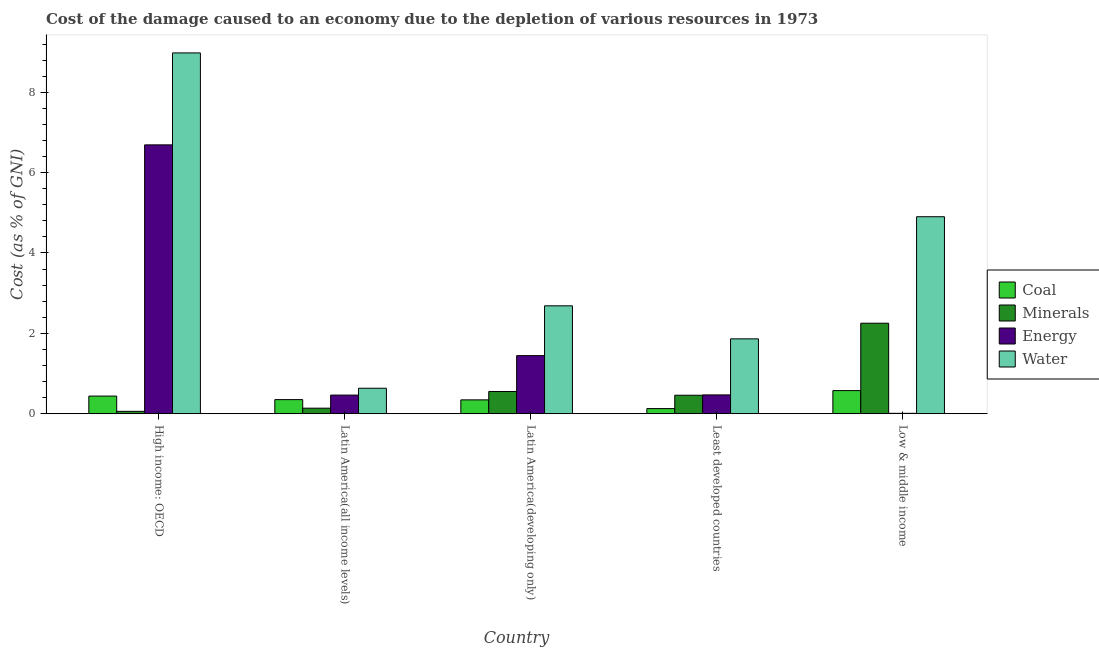How many groups of bars are there?
Offer a terse response. 5. Are the number of bars per tick equal to the number of legend labels?
Your answer should be very brief. Yes. How many bars are there on the 5th tick from the left?
Provide a short and direct response. 4. How many bars are there on the 1st tick from the right?
Give a very brief answer. 4. What is the label of the 2nd group of bars from the left?
Your answer should be compact. Latin America(all income levels). In how many cases, is the number of bars for a given country not equal to the number of legend labels?
Give a very brief answer. 0. What is the cost of damage due to depletion of energy in Least developed countries?
Make the answer very short. 0.47. Across all countries, what is the maximum cost of damage due to depletion of coal?
Your answer should be very brief. 0.58. Across all countries, what is the minimum cost of damage due to depletion of energy?
Your response must be concise. 0.01. In which country was the cost of damage due to depletion of energy maximum?
Keep it short and to the point. High income: OECD. What is the total cost of damage due to depletion of minerals in the graph?
Your response must be concise. 3.46. What is the difference between the cost of damage due to depletion of water in Latin America(developing only) and that in Low & middle income?
Offer a terse response. -2.22. What is the difference between the cost of damage due to depletion of water in Latin America(developing only) and the cost of damage due to depletion of energy in Least developed countries?
Give a very brief answer. 2.22. What is the average cost of damage due to depletion of energy per country?
Keep it short and to the point. 1.82. What is the difference between the cost of damage due to depletion of minerals and cost of damage due to depletion of energy in Least developed countries?
Ensure brevity in your answer.  -0.01. In how many countries, is the cost of damage due to depletion of energy greater than 1.6 %?
Make the answer very short. 1. What is the ratio of the cost of damage due to depletion of water in High income: OECD to that in Latin America(developing only)?
Provide a short and direct response. 3.34. What is the difference between the highest and the second highest cost of damage due to depletion of water?
Make the answer very short. 4.08. What is the difference between the highest and the lowest cost of damage due to depletion of coal?
Your response must be concise. 0.45. In how many countries, is the cost of damage due to depletion of water greater than the average cost of damage due to depletion of water taken over all countries?
Ensure brevity in your answer.  2. Is the sum of the cost of damage due to depletion of water in High income: OECD and Latin America(all income levels) greater than the maximum cost of damage due to depletion of energy across all countries?
Keep it short and to the point. Yes. What does the 2nd bar from the left in High income: OECD represents?
Your answer should be compact. Minerals. What does the 4th bar from the right in Latin America(developing only) represents?
Your answer should be compact. Coal. Is it the case that in every country, the sum of the cost of damage due to depletion of coal and cost of damage due to depletion of minerals is greater than the cost of damage due to depletion of energy?
Offer a terse response. No. What is the difference between two consecutive major ticks on the Y-axis?
Ensure brevity in your answer.  2. Does the graph contain any zero values?
Your response must be concise. No. Where does the legend appear in the graph?
Your response must be concise. Center right. How are the legend labels stacked?
Provide a short and direct response. Vertical. What is the title of the graph?
Your answer should be very brief. Cost of the damage caused to an economy due to the depletion of various resources in 1973 . What is the label or title of the X-axis?
Give a very brief answer. Country. What is the label or title of the Y-axis?
Ensure brevity in your answer.  Cost (as % of GNI). What is the Cost (as % of GNI) of Coal in High income: OECD?
Your answer should be compact. 0.44. What is the Cost (as % of GNI) in Minerals in High income: OECD?
Your answer should be very brief. 0.06. What is the Cost (as % of GNI) of Energy in High income: OECD?
Give a very brief answer. 6.69. What is the Cost (as % of GNI) in Water in High income: OECD?
Make the answer very short. 8.98. What is the Cost (as % of GNI) in Coal in Latin America(all income levels)?
Your answer should be compact. 0.35. What is the Cost (as % of GNI) of Minerals in Latin America(all income levels)?
Give a very brief answer. 0.14. What is the Cost (as % of GNI) in Energy in Latin America(all income levels)?
Keep it short and to the point. 0.46. What is the Cost (as % of GNI) in Water in Latin America(all income levels)?
Your answer should be compact. 0.63. What is the Cost (as % of GNI) in Coal in Latin America(developing only)?
Ensure brevity in your answer.  0.35. What is the Cost (as % of GNI) in Minerals in Latin America(developing only)?
Provide a short and direct response. 0.55. What is the Cost (as % of GNI) of Energy in Latin America(developing only)?
Your response must be concise. 1.45. What is the Cost (as % of GNI) of Water in Latin America(developing only)?
Your answer should be very brief. 2.69. What is the Cost (as % of GNI) in Coal in Least developed countries?
Provide a short and direct response. 0.13. What is the Cost (as % of GNI) in Minerals in Least developed countries?
Provide a succinct answer. 0.46. What is the Cost (as % of GNI) in Energy in Least developed countries?
Your answer should be compact. 0.47. What is the Cost (as % of GNI) of Water in Least developed countries?
Offer a very short reply. 1.86. What is the Cost (as % of GNI) of Coal in Low & middle income?
Offer a very short reply. 0.58. What is the Cost (as % of GNI) in Minerals in Low & middle income?
Make the answer very short. 2.25. What is the Cost (as % of GNI) of Energy in Low & middle income?
Offer a very short reply. 0.01. What is the Cost (as % of GNI) in Water in Low & middle income?
Provide a short and direct response. 4.9. Across all countries, what is the maximum Cost (as % of GNI) of Coal?
Give a very brief answer. 0.58. Across all countries, what is the maximum Cost (as % of GNI) in Minerals?
Your answer should be compact. 2.25. Across all countries, what is the maximum Cost (as % of GNI) of Energy?
Your answer should be compact. 6.69. Across all countries, what is the maximum Cost (as % of GNI) of Water?
Offer a terse response. 8.98. Across all countries, what is the minimum Cost (as % of GNI) in Coal?
Give a very brief answer. 0.13. Across all countries, what is the minimum Cost (as % of GNI) in Minerals?
Your response must be concise. 0.06. Across all countries, what is the minimum Cost (as % of GNI) of Energy?
Offer a very short reply. 0.01. Across all countries, what is the minimum Cost (as % of GNI) in Water?
Make the answer very short. 0.63. What is the total Cost (as % of GNI) in Coal in the graph?
Your response must be concise. 1.84. What is the total Cost (as % of GNI) of Minerals in the graph?
Make the answer very short. 3.46. What is the total Cost (as % of GNI) in Energy in the graph?
Make the answer very short. 9.08. What is the total Cost (as % of GNI) of Water in the graph?
Provide a succinct answer. 19.06. What is the difference between the Cost (as % of GNI) of Coal in High income: OECD and that in Latin America(all income levels)?
Your response must be concise. 0.09. What is the difference between the Cost (as % of GNI) of Minerals in High income: OECD and that in Latin America(all income levels)?
Ensure brevity in your answer.  -0.08. What is the difference between the Cost (as % of GNI) in Energy in High income: OECD and that in Latin America(all income levels)?
Ensure brevity in your answer.  6.23. What is the difference between the Cost (as % of GNI) in Water in High income: OECD and that in Latin America(all income levels)?
Your answer should be compact. 8.34. What is the difference between the Cost (as % of GNI) of Coal in High income: OECD and that in Latin America(developing only)?
Make the answer very short. 0.09. What is the difference between the Cost (as % of GNI) in Minerals in High income: OECD and that in Latin America(developing only)?
Provide a succinct answer. -0.49. What is the difference between the Cost (as % of GNI) of Energy in High income: OECD and that in Latin America(developing only)?
Your answer should be very brief. 5.24. What is the difference between the Cost (as % of GNI) of Water in High income: OECD and that in Latin America(developing only)?
Keep it short and to the point. 6.29. What is the difference between the Cost (as % of GNI) in Coal in High income: OECD and that in Least developed countries?
Provide a succinct answer. 0.31. What is the difference between the Cost (as % of GNI) in Minerals in High income: OECD and that in Least developed countries?
Offer a terse response. -0.4. What is the difference between the Cost (as % of GNI) in Energy in High income: OECD and that in Least developed countries?
Offer a very short reply. 6.22. What is the difference between the Cost (as % of GNI) in Water in High income: OECD and that in Least developed countries?
Provide a short and direct response. 7.12. What is the difference between the Cost (as % of GNI) in Coal in High income: OECD and that in Low & middle income?
Offer a terse response. -0.14. What is the difference between the Cost (as % of GNI) of Minerals in High income: OECD and that in Low & middle income?
Your response must be concise. -2.19. What is the difference between the Cost (as % of GNI) in Energy in High income: OECD and that in Low & middle income?
Offer a terse response. 6.68. What is the difference between the Cost (as % of GNI) in Water in High income: OECD and that in Low & middle income?
Ensure brevity in your answer.  4.08. What is the difference between the Cost (as % of GNI) of Coal in Latin America(all income levels) and that in Latin America(developing only)?
Provide a succinct answer. 0.01. What is the difference between the Cost (as % of GNI) in Minerals in Latin America(all income levels) and that in Latin America(developing only)?
Make the answer very short. -0.42. What is the difference between the Cost (as % of GNI) in Energy in Latin America(all income levels) and that in Latin America(developing only)?
Provide a short and direct response. -0.98. What is the difference between the Cost (as % of GNI) of Water in Latin America(all income levels) and that in Latin America(developing only)?
Ensure brevity in your answer.  -2.05. What is the difference between the Cost (as % of GNI) in Coal in Latin America(all income levels) and that in Least developed countries?
Your response must be concise. 0.22. What is the difference between the Cost (as % of GNI) of Minerals in Latin America(all income levels) and that in Least developed countries?
Offer a terse response. -0.32. What is the difference between the Cost (as % of GNI) of Energy in Latin America(all income levels) and that in Least developed countries?
Make the answer very short. -0. What is the difference between the Cost (as % of GNI) in Water in Latin America(all income levels) and that in Least developed countries?
Give a very brief answer. -1.23. What is the difference between the Cost (as % of GNI) of Coal in Latin America(all income levels) and that in Low & middle income?
Provide a succinct answer. -0.22. What is the difference between the Cost (as % of GNI) in Minerals in Latin America(all income levels) and that in Low & middle income?
Offer a very short reply. -2.11. What is the difference between the Cost (as % of GNI) in Energy in Latin America(all income levels) and that in Low & middle income?
Make the answer very short. 0.45. What is the difference between the Cost (as % of GNI) of Water in Latin America(all income levels) and that in Low & middle income?
Provide a short and direct response. -4.27. What is the difference between the Cost (as % of GNI) of Coal in Latin America(developing only) and that in Least developed countries?
Offer a terse response. 0.22. What is the difference between the Cost (as % of GNI) of Minerals in Latin America(developing only) and that in Least developed countries?
Provide a short and direct response. 0.09. What is the difference between the Cost (as % of GNI) in Energy in Latin America(developing only) and that in Least developed countries?
Ensure brevity in your answer.  0.98. What is the difference between the Cost (as % of GNI) of Water in Latin America(developing only) and that in Least developed countries?
Your answer should be very brief. 0.82. What is the difference between the Cost (as % of GNI) of Coal in Latin America(developing only) and that in Low & middle income?
Provide a short and direct response. -0.23. What is the difference between the Cost (as % of GNI) of Minerals in Latin America(developing only) and that in Low & middle income?
Your answer should be compact. -1.7. What is the difference between the Cost (as % of GNI) in Energy in Latin America(developing only) and that in Low & middle income?
Ensure brevity in your answer.  1.44. What is the difference between the Cost (as % of GNI) of Water in Latin America(developing only) and that in Low & middle income?
Your answer should be very brief. -2.22. What is the difference between the Cost (as % of GNI) in Coal in Least developed countries and that in Low & middle income?
Provide a short and direct response. -0.45. What is the difference between the Cost (as % of GNI) in Minerals in Least developed countries and that in Low & middle income?
Provide a short and direct response. -1.79. What is the difference between the Cost (as % of GNI) in Energy in Least developed countries and that in Low & middle income?
Your answer should be compact. 0.46. What is the difference between the Cost (as % of GNI) in Water in Least developed countries and that in Low & middle income?
Ensure brevity in your answer.  -3.04. What is the difference between the Cost (as % of GNI) in Coal in High income: OECD and the Cost (as % of GNI) in Minerals in Latin America(all income levels)?
Your answer should be very brief. 0.3. What is the difference between the Cost (as % of GNI) of Coal in High income: OECD and the Cost (as % of GNI) of Energy in Latin America(all income levels)?
Provide a short and direct response. -0.02. What is the difference between the Cost (as % of GNI) of Coal in High income: OECD and the Cost (as % of GNI) of Water in Latin America(all income levels)?
Your response must be concise. -0.2. What is the difference between the Cost (as % of GNI) of Minerals in High income: OECD and the Cost (as % of GNI) of Energy in Latin America(all income levels)?
Offer a very short reply. -0.4. What is the difference between the Cost (as % of GNI) in Minerals in High income: OECD and the Cost (as % of GNI) in Water in Latin America(all income levels)?
Provide a short and direct response. -0.57. What is the difference between the Cost (as % of GNI) in Energy in High income: OECD and the Cost (as % of GNI) in Water in Latin America(all income levels)?
Make the answer very short. 6.06. What is the difference between the Cost (as % of GNI) of Coal in High income: OECD and the Cost (as % of GNI) of Minerals in Latin America(developing only)?
Offer a terse response. -0.11. What is the difference between the Cost (as % of GNI) in Coal in High income: OECD and the Cost (as % of GNI) in Energy in Latin America(developing only)?
Provide a short and direct response. -1.01. What is the difference between the Cost (as % of GNI) of Coal in High income: OECD and the Cost (as % of GNI) of Water in Latin America(developing only)?
Offer a very short reply. -2.25. What is the difference between the Cost (as % of GNI) of Minerals in High income: OECD and the Cost (as % of GNI) of Energy in Latin America(developing only)?
Offer a terse response. -1.39. What is the difference between the Cost (as % of GNI) of Minerals in High income: OECD and the Cost (as % of GNI) of Water in Latin America(developing only)?
Provide a succinct answer. -2.63. What is the difference between the Cost (as % of GNI) of Energy in High income: OECD and the Cost (as % of GNI) of Water in Latin America(developing only)?
Your answer should be very brief. 4.01. What is the difference between the Cost (as % of GNI) in Coal in High income: OECD and the Cost (as % of GNI) in Minerals in Least developed countries?
Provide a succinct answer. -0.02. What is the difference between the Cost (as % of GNI) of Coal in High income: OECD and the Cost (as % of GNI) of Energy in Least developed countries?
Provide a short and direct response. -0.03. What is the difference between the Cost (as % of GNI) in Coal in High income: OECD and the Cost (as % of GNI) in Water in Least developed countries?
Offer a terse response. -1.42. What is the difference between the Cost (as % of GNI) of Minerals in High income: OECD and the Cost (as % of GNI) of Energy in Least developed countries?
Provide a short and direct response. -0.41. What is the difference between the Cost (as % of GNI) of Minerals in High income: OECD and the Cost (as % of GNI) of Water in Least developed countries?
Give a very brief answer. -1.8. What is the difference between the Cost (as % of GNI) in Energy in High income: OECD and the Cost (as % of GNI) in Water in Least developed countries?
Provide a short and direct response. 4.83. What is the difference between the Cost (as % of GNI) in Coal in High income: OECD and the Cost (as % of GNI) in Minerals in Low & middle income?
Offer a very short reply. -1.81. What is the difference between the Cost (as % of GNI) of Coal in High income: OECD and the Cost (as % of GNI) of Energy in Low & middle income?
Offer a terse response. 0.43. What is the difference between the Cost (as % of GNI) of Coal in High income: OECD and the Cost (as % of GNI) of Water in Low & middle income?
Your response must be concise. -4.46. What is the difference between the Cost (as % of GNI) of Minerals in High income: OECD and the Cost (as % of GNI) of Energy in Low & middle income?
Ensure brevity in your answer.  0.05. What is the difference between the Cost (as % of GNI) of Minerals in High income: OECD and the Cost (as % of GNI) of Water in Low & middle income?
Offer a very short reply. -4.84. What is the difference between the Cost (as % of GNI) in Energy in High income: OECD and the Cost (as % of GNI) in Water in Low & middle income?
Provide a succinct answer. 1.79. What is the difference between the Cost (as % of GNI) of Coal in Latin America(all income levels) and the Cost (as % of GNI) of Minerals in Latin America(developing only)?
Give a very brief answer. -0.2. What is the difference between the Cost (as % of GNI) of Coal in Latin America(all income levels) and the Cost (as % of GNI) of Energy in Latin America(developing only)?
Offer a terse response. -1.09. What is the difference between the Cost (as % of GNI) of Coal in Latin America(all income levels) and the Cost (as % of GNI) of Water in Latin America(developing only)?
Your answer should be very brief. -2.33. What is the difference between the Cost (as % of GNI) of Minerals in Latin America(all income levels) and the Cost (as % of GNI) of Energy in Latin America(developing only)?
Provide a short and direct response. -1.31. What is the difference between the Cost (as % of GNI) of Minerals in Latin America(all income levels) and the Cost (as % of GNI) of Water in Latin America(developing only)?
Provide a succinct answer. -2.55. What is the difference between the Cost (as % of GNI) in Energy in Latin America(all income levels) and the Cost (as % of GNI) in Water in Latin America(developing only)?
Give a very brief answer. -2.22. What is the difference between the Cost (as % of GNI) of Coal in Latin America(all income levels) and the Cost (as % of GNI) of Minerals in Least developed countries?
Ensure brevity in your answer.  -0.11. What is the difference between the Cost (as % of GNI) of Coal in Latin America(all income levels) and the Cost (as % of GNI) of Energy in Least developed countries?
Your answer should be compact. -0.12. What is the difference between the Cost (as % of GNI) in Coal in Latin America(all income levels) and the Cost (as % of GNI) in Water in Least developed countries?
Your response must be concise. -1.51. What is the difference between the Cost (as % of GNI) in Minerals in Latin America(all income levels) and the Cost (as % of GNI) in Energy in Least developed countries?
Provide a succinct answer. -0.33. What is the difference between the Cost (as % of GNI) in Minerals in Latin America(all income levels) and the Cost (as % of GNI) in Water in Least developed countries?
Offer a terse response. -1.73. What is the difference between the Cost (as % of GNI) in Energy in Latin America(all income levels) and the Cost (as % of GNI) in Water in Least developed countries?
Keep it short and to the point. -1.4. What is the difference between the Cost (as % of GNI) of Coal in Latin America(all income levels) and the Cost (as % of GNI) of Minerals in Low & middle income?
Make the answer very short. -1.9. What is the difference between the Cost (as % of GNI) of Coal in Latin America(all income levels) and the Cost (as % of GNI) of Energy in Low & middle income?
Keep it short and to the point. 0.34. What is the difference between the Cost (as % of GNI) of Coal in Latin America(all income levels) and the Cost (as % of GNI) of Water in Low & middle income?
Provide a succinct answer. -4.55. What is the difference between the Cost (as % of GNI) of Minerals in Latin America(all income levels) and the Cost (as % of GNI) of Energy in Low & middle income?
Give a very brief answer. 0.13. What is the difference between the Cost (as % of GNI) in Minerals in Latin America(all income levels) and the Cost (as % of GNI) in Water in Low & middle income?
Your answer should be compact. -4.76. What is the difference between the Cost (as % of GNI) in Energy in Latin America(all income levels) and the Cost (as % of GNI) in Water in Low & middle income?
Your answer should be very brief. -4.44. What is the difference between the Cost (as % of GNI) of Coal in Latin America(developing only) and the Cost (as % of GNI) of Minerals in Least developed countries?
Ensure brevity in your answer.  -0.12. What is the difference between the Cost (as % of GNI) of Coal in Latin America(developing only) and the Cost (as % of GNI) of Energy in Least developed countries?
Your response must be concise. -0.12. What is the difference between the Cost (as % of GNI) in Coal in Latin America(developing only) and the Cost (as % of GNI) in Water in Least developed countries?
Make the answer very short. -1.52. What is the difference between the Cost (as % of GNI) in Minerals in Latin America(developing only) and the Cost (as % of GNI) in Energy in Least developed countries?
Keep it short and to the point. 0.09. What is the difference between the Cost (as % of GNI) in Minerals in Latin America(developing only) and the Cost (as % of GNI) in Water in Least developed countries?
Keep it short and to the point. -1.31. What is the difference between the Cost (as % of GNI) of Energy in Latin America(developing only) and the Cost (as % of GNI) of Water in Least developed countries?
Your answer should be very brief. -0.42. What is the difference between the Cost (as % of GNI) of Coal in Latin America(developing only) and the Cost (as % of GNI) of Minerals in Low & middle income?
Provide a succinct answer. -1.91. What is the difference between the Cost (as % of GNI) in Coal in Latin America(developing only) and the Cost (as % of GNI) in Energy in Low & middle income?
Offer a very short reply. 0.33. What is the difference between the Cost (as % of GNI) in Coal in Latin America(developing only) and the Cost (as % of GNI) in Water in Low & middle income?
Your answer should be compact. -4.56. What is the difference between the Cost (as % of GNI) in Minerals in Latin America(developing only) and the Cost (as % of GNI) in Energy in Low & middle income?
Keep it short and to the point. 0.54. What is the difference between the Cost (as % of GNI) of Minerals in Latin America(developing only) and the Cost (as % of GNI) of Water in Low & middle income?
Offer a very short reply. -4.35. What is the difference between the Cost (as % of GNI) of Energy in Latin America(developing only) and the Cost (as % of GNI) of Water in Low & middle income?
Your response must be concise. -3.46. What is the difference between the Cost (as % of GNI) in Coal in Least developed countries and the Cost (as % of GNI) in Minerals in Low & middle income?
Keep it short and to the point. -2.12. What is the difference between the Cost (as % of GNI) of Coal in Least developed countries and the Cost (as % of GNI) of Energy in Low & middle income?
Provide a short and direct response. 0.12. What is the difference between the Cost (as % of GNI) in Coal in Least developed countries and the Cost (as % of GNI) in Water in Low & middle income?
Provide a succinct answer. -4.77. What is the difference between the Cost (as % of GNI) of Minerals in Least developed countries and the Cost (as % of GNI) of Energy in Low & middle income?
Your answer should be very brief. 0.45. What is the difference between the Cost (as % of GNI) in Minerals in Least developed countries and the Cost (as % of GNI) in Water in Low & middle income?
Provide a short and direct response. -4.44. What is the difference between the Cost (as % of GNI) in Energy in Least developed countries and the Cost (as % of GNI) in Water in Low & middle income?
Provide a short and direct response. -4.43. What is the average Cost (as % of GNI) of Coal per country?
Offer a very short reply. 0.37. What is the average Cost (as % of GNI) in Minerals per country?
Your answer should be very brief. 0.69. What is the average Cost (as % of GNI) of Energy per country?
Provide a short and direct response. 1.82. What is the average Cost (as % of GNI) of Water per country?
Your answer should be very brief. 3.81. What is the difference between the Cost (as % of GNI) of Coal and Cost (as % of GNI) of Minerals in High income: OECD?
Keep it short and to the point. 0.38. What is the difference between the Cost (as % of GNI) of Coal and Cost (as % of GNI) of Energy in High income: OECD?
Your answer should be compact. -6.25. What is the difference between the Cost (as % of GNI) of Coal and Cost (as % of GNI) of Water in High income: OECD?
Keep it short and to the point. -8.54. What is the difference between the Cost (as % of GNI) of Minerals and Cost (as % of GNI) of Energy in High income: OECD?
Your answer should be very brief. -6.63. What is the difference between the Cost (as % of GNI) in Minerals and Cost (as % of GNI) in Water in High income: OECD?
Offer a terse response. -8.92. What is the difference between the Cost (as % of GNI) of Energy and Cost (as % of GNI) of Water in High income: OECD?
Provide a short and direct response. -2.29. What is the difference between the Cost (as % of GNI) in Coal and Cost (as % of GNI) in Minerals in Latin America(all income levels)?
Keep it short and to the point. 0.21. What is the difference between the Cost (as % of GNI) in Coal and Cost (as % of GNI) in Energy in Latin America(all income levels)?
Keep it short and to the point. -0.11. What is the difference between the Cost (as % of GNI) of Coal and Cost (as % of GNI) of Water in Latin America(all income levels)?
Make the answer very short. -0.28. What is the difference between the Cost (as % of GNI) in Minerals and Cost (as % of GNI) in Energy in Latin America(all income levels)?
Your answer should be compact. -0.33. What is the difference between the Cost (as % of GNI) in Minerals and Cost (as % of GNI) in Water in Latin America(all income levels)?
Make the answer very short. -0.5. What is the difference between the Cost (as % of GNI) in Energy and Cost (as % of GNI) in Water in Latin America(all income levels)?
Offer a very short reply. -0.17. What is the difference between the Cost (as % of GNI) in Coal and Cost (as % of GNI) in Minerals in Latin America(developing only)?
Ensure brevity in your answer.  -0.21. What is the difference between the Cost (as % of GNI) of Coal and Cost (as % of GNI) of Energy in Latin America(developing only)?
Give a very brief answer. -1.1. What is the difference between the Cost (as % of GNI) of Coal and Cost (as % of GNI) of Water in Latin America(developing only)?
Keep it short and to the point. -2.34. What is the difference between the Cost (as % of GNI) of Minerals and Cost (as % of GNI) of Energy in Latin America(developing only)?
Ensure brevity in your answer.  -0.89. What is the difference between the Cost (as % of GNI) in Minerals and Cost (as % of GNI) in Water in Latin America(developing only)?
Your response must be concise. -2.13. What is the difference between the Cost (as % of GNI) of Energy and Cost (as % of GNI) of Water in Latin America(developing only)?
Your answer should be compact. -1.24. What is the difference between the Cost (as % of GNI) in Coal and Cost (as % of GNI) in Minerals in Least developed countries?
Offer a very short reply. -0.33. What is the difference between the Cost (as % of GNI) of Coal and Cost (as % of GNI) of Energy in Least developed countries?
Your response must be concise. -0.34. What is the difference between the Cost (as % of GNI) in Coal and Cost (as % of GNI) in Water in Least developed countries?
Make the answer very short. -1.74. What is the difference between the Cost (as % of GNI) of Minerals and Cost (as % of GNI) of Energy in Least developed countries?
Give a very brief answer. -0.01. What is the difference between the Cost (as % of GNI) in Minerals and Cost (as % of GNI) in Water in Least developed countries?
Your answer should be very brief. -1.4. What is the difference between the Cost (as % of GNI) in Energy and Cost (as % of GNI) in Water in Least developed countries?
Offer a terse response. -1.4. What is the difference between the Cost (as % of GNI) of Coal and Cost (as % of GNI) of Minerals in Low & middle income?
Your response must be concise. -1.68. What is the difference between the Cost (as % of GNI) of Coal and Cost (as % of GNI) of Energy in Low & middle income?
Your response must be concise. 0.57. What is the difference between the Cost (as % of GNI) of Coal and Cost (as % of GNI) of Water in Low & middle income?
Provide a short and direct response. -4.33. What is the difference between the Cost (as % of GNI) in Minerals and Cost (as % of GNI) in Energy in Low & middle income?
Ensure brevity in your answer.  2.24. What is the difference between the Cost (as % of GNI) of Minerals and Cost (as % of GNI) of Water in Low & middle income?
Offer a terse response. -2.65. What is the difference between the Cost (as % of GNI) of Energy and Cost (as % of GNI) of Water in Low & middle income?
Your response must be concise. -4.89. What is the ratio of the Cost (as % of GNI) in Coal in High income: OECD to that in Latin America(all income levels)?
Provide a short and direct response. 1.25. What is the ratio of the Cost (as % of GNI) of Minerals in High income: OECD to that in Latin America(all income levels)?
Provide a short and direct response. 0.43. What is the ratio of the Cost (as % of GNI) of Energy in High income: OECD to that in Latin America(all income levels)?
Ensure brevity in your answer.  14.42. What is the ratio of the Cost (as % of GNI) of Water in High income: OECD to that in Latin America(all income levels)?
Your answer should be compact. 14.15. What is the ratio of the Cost (as % of GNI) of Coal in High income: OECD to that in Latin America(developing only)?
Provide a succinct answer. 1.27. What is the ratio of the Cost (as % of GNI) of Minerals in High income: OECD to that in Latin America(developing only)?
Give a very brief answer. 0.11. What is the ratio of the Cost (as % of GNI) of Energy in High income: OECD to that in Latin America(developing only)?
Give a very brief answer. 4.63. What is the ratio of the Cost (as % of GNI) in Water in High income: OECD to that in Latin America(developing only)?
Your response must be concise. 3.34. What is the ratio of the Cost (as % of GNI) of Coal in High income: OECD to that in Least developed countries?
Give a very brief answer. 3.43. What is the ratio of the Cost (as % of GNI) of Minerals in High income: OECD to that in Least developed countries?
Keep it short and to the point. 0.13. What is the ratio of the Cost (as % of GNI) of Energy in High income: OECD to that in Least developed countries?
Offer a very short reply. 14.28. What is the ratio of the Cost (as % of GNI) in Water in High income: OECD to that in Least developed countries?
Your answer should be very brief. 4.82. What is the ratio of the Cost (as % of GNI) of Coal in High income: OECD to that in Low & middle income?
Your response must be concise. 0.76. What is the ratio of the Cost (as % of GNI) of Minerals in High income: OECD to that in Low & middle income?
Your response must be concise. 0.03. What is the ratio of the Cost (as % of GNI) in Energy in High income: OECD to that in Low & middle income?
Your answer should be compact. 639.01. What is the ratio of the Cost (as % of GNI) in Water in High income: OECD to that in Low & middle income?
Your answer should be compact. 1.83. What is the ratio of the Cost (as % of GNI) in Coal in Latin America(all income levels) to that in Latin America(developing only)?
Provide a succinct answer. 1.02. What is the ratio of the Cost (as % of GNI) in Minerals in Latin America(all income levels) to that in Latin America(developing only)?
Your response must be concise. 0.25. What is the ratio of the Cost (as % of GNI) of Energy in Latin America(all income levels) to that in Latin America(developing only)?
Your answer should be compact. 0.32. What is the ratio of the Cost (as % of GNI) of Water in Latin America(all income levels) to that in Latin America(developing only)?
Keep it short and to the point. 0.24. What is the ratio of the Cost (as % of GNI) in Coal in Latin America(all income levels) to that in Least developed countries?
Make the answer very short. 2.74. What is the ratio of the Cost (as % of GNI) in Minerals in Latin America(all income levels) to that in Least developed countries?
Offer a very short reply. 0.3. What is the ratio of the Cost (as % of GNI) in Energy in Latin America(all income levels) to that in Least developed countries?
Keep it short and to the point. 0.99. What is the ratio of the Cost (as % of GNI) in Water in Latin America(all income levels) to that in Least developed countries?
Provide a short and direct response. 0.34. What is the ratio of the Cost (as % of GNI) in Coal in Latin America(all income levels) to that in Low & middle income?
Your response must be concise. 0.61. What is the ratio of the Cost (as % of GNI) in Minerals in Latin America(all income levels) to that in Low & middle income?
Provide a succinct answer. 0.06. What is the ratio of the Cost (as % of GNI) of Energy in Latin America(all income levels) to that in Low & middle income?
Your answer should be very brief. 44.33. What is the ratio of the Cost (as % of GNI) of Water in Latin America(all income levels) to that in Low & middle income?
Keep it short and to the point. 0.13. What is the ratio of the Cost (as % of GNI) of Coal in Latin America(developing only) to that in Least developed countries?
Your response must be concise. 2.69. What is the ratio of the Cost (as % of GNI) of Minerals in Latin America(developing only) to that in Least developed countries?
Your answer should be compact. 1.2. What is the ratio of the Cost (as % of GNI) in Energy in Latin America(developing only) to that in Least developed countries?
Give a very brief answer. 3.09. What is the ratio of the Cost (as % of GNI) of Water in Latin America(developing only) to that in Least developed countries?
Your answer should be very brief. 1.44. What is the ratio of the Cost (as % of GNI) in Coal in Latin America(developing only) to that in Low & middle income?
Keep it short and to the point. 0.6. What is the ratio of the Cost (as % of GNI) in Minerals in Latin America(developing only) to that in Low & middle income?
Provide a short and direct response. 0.25. What is the ratio of the Cost (as % of GNI) of Energy in Latin America(developing only) to that in Low & middle income?
Keep it short and to the point. 138.13. What is the ratio of the Cost (as % of GNI) in Water in Latin America(developing only) to that in Low & middle income?
Give a very brief answer. 0.55. What is the ratio of the Cost (as % of GNI) of Coal in Least developed countries to that in Low & middle income?
Offer a very short reply. 0.22. What is the ratio of the Cost (as % of GNI) of Minerals in Least developed countries to that in Low & middle income?
Offer a terse response. 0.2. What is the ratio of the Cost (as % of GNI) in Energy in Least developed countries to that in Low & middle income?
Keep it short and to the point. 44.74. What is the ratio of the Cost (as % of GNI) of Water in Least developed countries to that in Low & middle income?
Offer a very short reply. 0.38. What is the difference between the highest and the second highest Cost (as % of GNI) in Coal?
Ensure brevity in your answer.  0.14. What is the difference between the highest and the second highest Cost (as % of GNI) in Minerals?
Make the answer very short. 1.7. What is the difference between the highest and the second highest Cost (as % of GNI) in Energy?
Offer a terse response. 5.24. What is the difference between the highest and the second highest Cost (as % of GNI) of Water?
Offer a terse response. 4.08. What is the difference between the highest and the lowest Cost (as % of GNI) in Coal?
Offer a terse response. 0.45. What is the difference between the highest and the lowest Cost (as % of GNI) in Minerals?
Keep it short and to the point. 2.19. What is the difference between the highest and the lowest Cost (as % of GNI) in Energy?
Offer a very short reply. 6.68. What is the difference between the highest and the lowest Cost (as % of GNI) in Water?
Give a very brief answer. 8.34. 